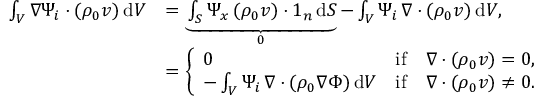Convert formula to latex. <formula><loc_0><loc_0><loc_500><loc_500>\begin{array} { r l } { \int _ { V } \nabla \Psi _ { i } \cdot ( \rho _ { 0 } v ) \, d V } & { = \underbrace { \int _ { S } \Psi _ { x } \, ( \rho _ { 0 } v ) \cdot 1 _ { n } \, d S } _ { 0 } - \int _ { V } \Psi _ { i } \, \nabla \cdot ( \rho _ { 0 } v ) \, d V , } \\ & { = \left \{ \begin{array} { l l } { 0 } & { i f \quad \nabla \cdot ( \rho _ { 0 } v ) = 0 , } \\ { - \int _ { V } \Psi _ { i } \, \nabla \cdot ( \rho _ { 0 } \nabla \Phi ) \, d V } & { i f \quad \nabla \cdot ( \rho _ { 0 } v ) \neq 0 . } \end{array} } \end{array}</formula> 